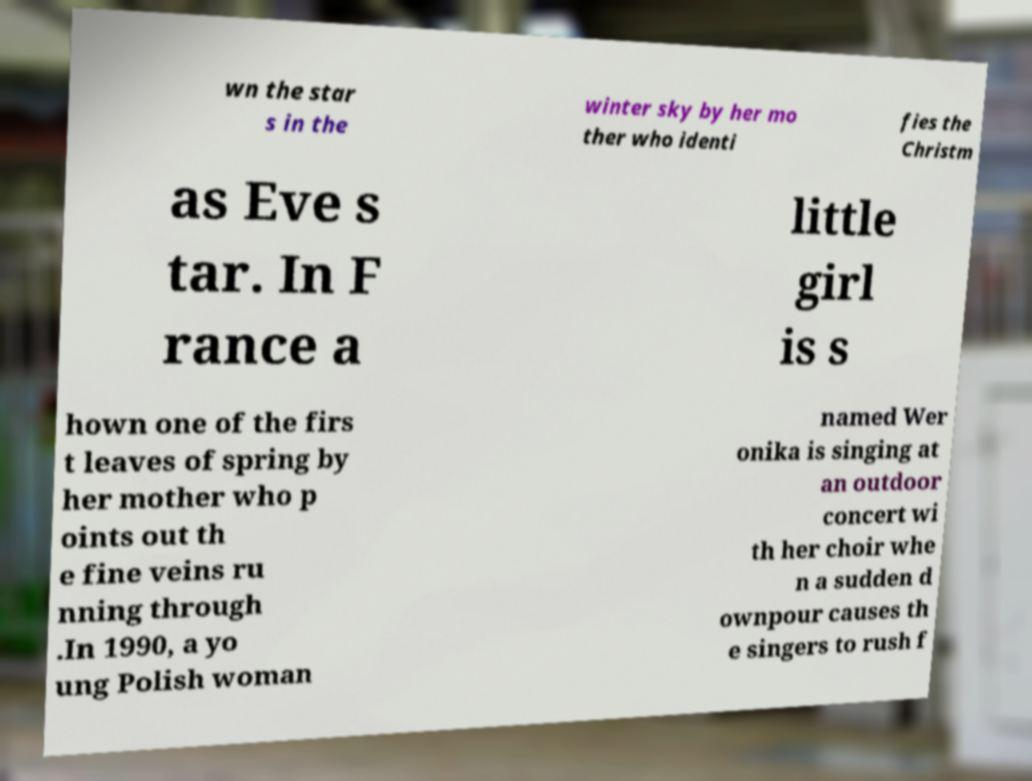Can you accurately transcribe the text from the provided image for me? wn the star s in the winter sky by her mo ther who identi fies the Christm as Eve s tar. In F rance a little girl is s hown one of the firs t leaves of spring by her mother who p oints out th e fine veins ru nning through .In 1990, a yo ung Polish woman named Wer onika is singing at an outdoor concert wi th her choir whe n a sudden d ownpour causes th e singers to rush f 